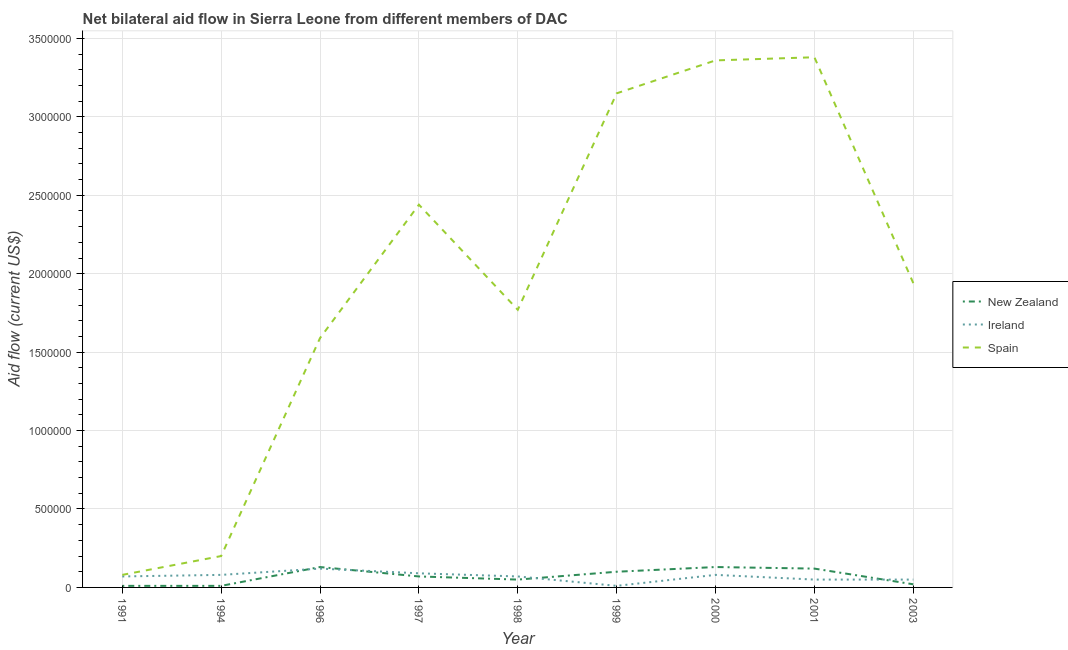How many different coloured lines are there?
Ensure brevity in your answer.  3. Is the number of lines equal to the number of legend labels?
Ensure brevity in your answer.  Yes. What is the amount of aid provided by spain in 1991?
Provide a succinct answer. 8.00e+04. Across all years, what is the maximum amount of aid provided by spain?
Give a very brief answer. 3.38e+06. Across all years, what is the minimum amount of aid provided by ireland?
Your answer should be compact. 10000. In which year was the amount of aid provided by new zealand maximum?
Your answer should be very brief. 1996. What is the total amount of aid provided by new zealand in the graph?
Give a very brief answer. 6.40e+05. What is the difference between the amount of aid provided by new zealand in 1998 and that in 1999?
Make the answer very short. -5.00e+04. What is the difference between the amount of aid provided by ireland in 1991 and the amount of aid provided by new zealand in 1996?
Keep it short and to the point. -6.00e+04. What is the average amount of aid provided by new zealand per year?
Make the answer very short. 7.11e+04. In the year 1991, what is the difference between the amount of aid provided by new zealand and amount of aid provided by ireland?
Ensure brevity in your answer.  -6.00e+04. What is the ratio of the amount of aid provided by new zealand in 1996 to that in 2003?
Your answer should be compact. 6.5. Is the amount of aid provided by ireland in 1991 less than that in 1996?
Provide a short and direct response. Yes. Is the difference between the amount of aid provided by ireland in 1991 and 2000 greater than the difference between the amount of aid provided by new zealand in 1991 and 2000?
Your response must be concise. Yes. What is the difference between the highest and the second highest amount of aid provided by spain?
Your answer should be compact. 2.00e+04. What is the difference between the highest and the lowest amount of aid provided by ireland?
Your response must be concise. 1.10e+05. Is it the case that in every year, the sum of the amount of aid provided by new zealand and amount of aid provided by ireland is greater than the amount of aid provided by spain?
Your response must be concise. No. Does the amount of aid provided by spain monotonically increase over the years?
Your answer should be compact. No. How many lines are there?
Provide a succinct answer. 3. How many years are there in the graph?
Provide a succinct answer. 9. Are the values on the major ticks of Y-axis written in scientific E-notation?
Offer a very short reply. No. Does the graph contain grids?
Make the answer very short. Yes. How many legend labels are there?
Your answer should be compact. 3. What is the title of the graph?
Provide a succinct answer. Net bilateral aid flow in Sierra Leone from different members of DAC. What is the Aid flow (current US$) in Spain in 1991?
Keep it short and to the point. 8.00e+04. What is the Aid flow (current US$) in New Zealand in 1994?
Provide a short and direct response. 10000. What is the Aid flow (current US$) in New Zealand in 1996?
Provide a short and direct response. 1.30e+05. What is the Aid flow (current US$) of Ireland in 1996?
Keep it short and to the point. 1.20e+05. What is the Aid flow (current US$) of Spain in 1996?
Keep it short and to the point. 1.59e+06. What is the Aid flow (current US$) in New Zealand in 1997?
Offer a terse response. 7.00e+04. What is the Aid flow (current US$) of Spain in 1997?
Give a very brief answer. 2.44e+06. What is the Aid flow (current US$) in Spain in 1998?
Provide a succinct answer. 1.77e+06. What is the Aid flow (current US$) of Ireland in 1999?
Provide a succinct answer. 10000. What is the Aid flow (current US$) of Spain in 1999?
Your answer should be compact. 3.15e+06. What is the Aid flow (current US$) of New Zealand in 2000?
Make the answer very short. 1.30e+05. What is the Aid flow (current US$) in Spain in 2000?
Make the answer very short. 3.36e+06. What is the Aid flow (current US$) in Ireland in 2001?
Offer a very short reply. 5.00e+04. What is the Aid flow (current US$) in Spain in 2001?
Keep it short and to the point. 3.38e+06. What is the Aid flow (current US$) in Spain in 2003?
Give a very brief answer. 1.94e+06. Across all years, what is the maximum Aid flow (current US$) in Spain?
Ensure brevity in your answer.  3.38e+06. Across all years, what is the minimum Aid flow (current US$) in Ireland?
Provide a short and direct response. 10000. Across all years, what is the minimum Aid flow (current US$) of Spain?
Your answer should be compact. 8.00e+04. What is the total Aid flow (current US$) of New Zealand in the graph?
Your answer should be very brief. 6.40e+05. What is the total Aid flow (current US$) in Ireland in the graph?
Offer a very short reply. 6.20e+05. What is the total Aid flow (current US$) in Spain in the graph?
Ensure brevity in your answer.  1.79e+07. What is the difference between the Aid flow (current US$) in Ireland in 1991 and that in 1994?
Provide a short and direct response. -10000. What is the difference between the Aid flow (current US$) in Spain in 1991 and that in 1994?
Ensure brevity in your answer.  -1.20e+05. What is the difference between the Aid flow (current US$) in New Zealand in 1991 and that in 1996?
Your answer should be very brief. -1.20e+05. What is the difference between the Aid flow (current US$) in Spain in 1991 and that in 1996?
Your response must be concise. -1.51e+06. What is the difference between the Aid flow (current US$) of Ireland in 1991 and that in 1997?
Give a very brief answer. -2.00e+04. What is the difference between the Aid flow (current US$) of Spain in 1991 and that in 1997?
Offer a terse response. -2.36e+06. What is the difference between the Aid flow (current US$) of New Zealand in 1991 and that in 1998?
Give a very brief answer. -4.00e+04. What is the difference between the Aid flow (current US$) in Ireland in 1991 and that in 1998?
Provide a succinct answer. 0. What is the difference between the Aid flow (current US$) in Spain in 1991 and that in 1998?
Offer a terse response. -1.69e+06. What is the difference between the Aid flow (current US$) in New Zealand in 1991 and that in 1999?
Your answer should be compact. -9.00e+04. What is the difference between the Aid flow (current US$) of Ireland in 1991 and that in 1999?
Provide a short and direct response. 6.00e+04. What is the difference between the Aid flow (current US$) in Spain in 1991 and that in 1999?
Ensure brevity in your answer.  -3.07e+06. What is the difference between the Aid flow (current US$) of Spain in 1991 and that in 2000?
Provide a succinct answer. -3.28e+06. What is the difference between the Aid flow (current US$) of Ireland in 1991 and that in 2001?
Your response must be concise. 2.00e+04. What is the difference between the Aid flow (current US$) of Spain in 1991 and that in 2001?
Your response must be concise. -3.30e+06. What is the difference between the Aid flow (current US$) in Ireland in 1991 and that in 2003?
Make the answer very short. 2.00e+04. What is the difference between the Aid flow (current US$) of Spain in 1991 and that in 2003?
Provide a short and direct response. -1.86e+06. What is the difference between the Aid flow (current US$) of New Zealand in 1994 and that in 1996?
Offer a terse response. -1.20e+05. What is the difference between the Aid flow (current US$) of Spain in 1994 and that in 1996?
Your answer should be compact. -1.39e+06. What is the difference between the Aid flow (current US$) of New Zealand in 1994 and that in 1997?
Offer a very short reply. -6.00e+04. What is the difference between the Aid flow (current US$) of Ireland in 1994 and that in 1997?
Offer a terse response. -10000. What is the difference between the Aid flow (current US$) in Spain in 1994 and that in 1997?
Offer a terse response. -2.24e+06. What is the difference between the Aid flow (current US$) in Ireland in 1994 and that in 1998?
Give a very brief answer. 10000. What is the difference between the Aid flow (current US$) in Spain in 1994 and that in 1998?
Keep it short and to the point. -1.57e+06. What is the difference between the Aid flow (current US$) of New Zealand in 1994 and that in 1999?
Provide a short and direct response. -9.00e+04. What is the difference between the Aid flow (current US$) of Ireland in 1994 and that in 1999?
Offer a very short reply. 7.00e+04. What is the difference between the Aid flow (current US$) of Spain in 1994 and that in 1999?
Give a very brief answer. -2.95e+06. What is the difference between the Aid flow (current US$) of New Zealand in 1994 and that in 2000?
Ensure brevity in your answer.  -1.20e+05. What is the difference between the Aid flow (current US$) of Spain in 1994 and that in 2000?
Ensure brevity in your answer.  -3.16e+06. What is the difference between the Aid flow (current US$) of New Zealand in 1994 and that in 2001?
Make the answer very short. -1.10e+05. What is the difference between the Aid flow (current US$) of Ireland in 1994 and that in 2001?
Provide a succinct answer. 3.00e+04. What is the difference between the Aid flow (current US$) in Spain in 1994 and that in 2001?
Your answer should be compact. -3.18e+06. What is the difference between the Aid flow (current US$) of Ireland in 1994 and that in 2003?
Ensure brevity in your answer.  3.00e+04. What is the difference between the Aid flow (current US$) in Spain in 1994 and that in 2003?
Make the answer very short. -1.74e+06. What is the difference between the Aid flow (current US$) of Ireland in 1996 and that in 1997?
Ensure brevity in your answer.  3.00e+04. What is the difference between the Aid flow (current US$) in Spain in 1996 and that in 1997?
Ensure brevity in your answer.  -8.50e+05. What is the difference between the Aid flow (current US$) of New Zealand in 1996 and that in 1998?
Offer a terse response. 8.00e+04. What is the difference between the Aid flow (current US$) in New Zealand in 1996 and that in 1999?
Provide a succinct answer. 3.00e+04. What is the difference between the Aid flow (current US$) of Spain in 1996 and that in 1999?
Offer a terse response. -1.56e+06. What is the difference between the Aid flow (current US$) in New Zealand in 1996 and that in 2000?
Your answer should be very brief. 0. What is the difference between the Aid flow (current US$) in Ireland in 1996 and that in 2000?
Keep it short and to the point. 4.00e+04. What is the difference between the Aid flow (current US$) of Spain in 1996 and that in 2000?
Offer a terse response. -1.77e+06. What is the difference between the Aid flow (current US$) of New Zealand in 1996 and that in 2001?
Keep it short and to the point. 10000. What is the difference between the Aid flow (current US$) in Spain in 1996 and that in 2001?
Offer a very short reply. -1.79e+06. What is the difference between the Aid flow (current US$) in Spain in 1996 and that in 2003?
Give a very brief answer. -3.50e+05. What is the difference between the Aid flow (current US$) in New Zealand in 1997 and that in 1998?
Your answer should be very brief. 2.00e+04. What is the difference between the Aid flow (current US$) in Spain in 1997 and that in 1998?
Offer a very short reply. 6.70e+05. What is the difference between the Aid flow (current US$) in New Zealand in 1997 and that in 1999?
Offer a very short reply. -3.00e+04. What is the difference between the Aid flow (current US$) in Spain in 1997 and that in 1999?
Offer a very short reply. -7.10e+05. What is the difference between the Aid flow (current US$) of Spain in 1997 and that in 2000?
Your response must be concise. -9.20e+05. What is the difference between the Aid flow (current US$) in Spain in 1997 and that in 2001?
Your response must be concise. -9.40e+05. What is the difference between the Aid flow (current US$) of Ireland in 1997 and that in 2003?
Your answer should be compact. 4.00e+04. What is the difference between the Aid flow (current US$) of Ireland in 1998 and that in 1999?
Keep it short and to the point. 6.00e+04. What is the difference between the Aid flow (current US$) in Spain in 1998 and that in 1999?
Your answer should be compact. -1.38e+06. What is the difference between the Aid flow (current US$) of Ireland in 1998 and that in 2000?
Provide a succinct answer. -10000. What is the difference between the Aid flow (current US$) of Spain in 1998 and that in 2000?
Give a very brief answer. -1.59e+06. What is the difference between the Aid flow (current US$) of Ireland in 1998 and that in 2001?
Provide a succinct answer. 2.00e+04. What is the difference between the Aid flow (current US$) of Spain in 1998 and that in 2001?
Make the answer very short. -1.61e+06. What is the difference between the Aid flow (current US$) of Ireland in 1998 and that in 2003?
Ensure brevity in your answer.  2.00e+04. What is the difference between the Aid flow (current US$) in Spain in 1998 and that in 2003?
Offer a terse response. -1.70e+05. What is the difference between the Aid flow (current US$) of Ireland in 1999 and that in 2000?
Ensure brevity in your answer.  -7.00e+04. What is the difference between the Aid flow (current US$) of New Zealand in 1999 and that in 2001?
Give a very brief answer. -2.00e+04. What is the difference between the Aid flow (current US$) in Ireland in 1999 and that in 2001?
Your response must be concise. -4.00e+04. What is the difference between the Aid flow (current US$) of Spain in 1999 and that in 2001?
Your answer should be very brief. -2.30e+05. What is the difference between the Aid flow (current US$) in New Zealand in 1999 and that in 2003?
Offer a terse response. 8.00e+04. What is the difference between the Aid flow (current US$) of Ireland in 1999 and that in 2003?
Your response must be concise. -4.00e+04. What is the difference between the Aid flow (current US$) of Spain in 1999 and that in 2003?
Provide a short and direct response. 1.21e+06. What is the difference between the Aid flow (current US$) in Spain in 2000 and that in 2001?
Give a very brief answer. -2.00e+04. What is the difference between the Aid flow (current US$) in Ireland in 2000 and that in 2003?
Give a very brief answer. 3.00e+04. What is the difference between the Aid flow (current US$) of Spain in 2000 and that in 2003?
Keep it short and to the point. 1.42e+06. What is the difference between the Aid flow (current US$) of Spain in 2001 and that in 2003?
Your answer should be very brief. 1.44e+06. What is the difference between the Aid flow (current US$) in New Zealand in 1991 and the Aid flow (current US$) in Ireland in 1994?
Offer a terse response. -7.00e+04. What is the difference between the Aid flow (current US$) in Ireland in 1991 and the Aid flow (current US$) in Spain in 1994?
Your answer should be very brief. -1.30e+05. What is the difference between the Aid flow (current US$) in New Zealand in 1991 and the Aid flow (current US$) in Spain in 1996?
Ensure brevity in your answer.  -1.58e+06. What is the difference between the Aid flow (current US$) of Ireland in 1991 and the Aid flow (current US$) of Spain in 1996?
Give a very brief answer. -1.52e+06. What is the difference between the Aid flow (current US$) in New Zealand in 1991 and the Aid flow (current US$) in Spain in 1997?
Give a very brief answer. -2.43e+06. What is the difference between the Aid flow (current US$) in Ireland in 1991 and the Aid flow (current US$) in Spain in 1997?
Give a very brief answer. -2.37e+06. What is the difference between the Aid flow (current US$) of New Zealand in 1991 and the Aid flow (current US$) of Ireland in 1998?
Provide a succinct answer. -6.00e+04. What is the difference between the Aid flow (current US$) of New Zealand in 1991 and the Aid flow (current US$) of Spain in 1998?
Your answer should be very brief. -1.76e+06. What is the difference between the Aid flow (current US$) of Ireland in 1991 and the Aid flow (current US$) of Spain in 1998?
Offer a very short reply. -1.70e+06. What is the difference between the Aid flow (current US$) in New Zealand in 1991 and the Aid flow (current US$) in Spain in 1999?
Offer a very short reply. -3.14e+06. What is the difference between the Aid flow (current US$) in Ireland in 1991 and the Aid flow (current US$) in Spain in 1999?
Your answer should be very brief. -3.08e+06. What is the difference between the Aid flow (current US$) in New Zealand in 1991 and the Aid flow (current US$) in Ireland in 2000?
Your answer should be compact. -7.00e+04. What is the difference between the Aid flow (current US$) of New Zealand in 1991 and the Aid flow (current US$) of Spain in 2000?
Give a very brief answer. -3.35e+06. What is the difference between the Aid flow (current US$) in Ireland in 1991 and the Aid flow (current US$) in Spain in 2000?
Provide a succinct answer. -3.29e+06. What is the difference between the Aid flow (current US$) of New Zealand in 1991 and the Aid flow (current US$) of Ireland in 2001?
Keep it short and to the point. -4.00e+04. What is the difference between the Aid flow (current US$) of New Zealand in 1991 and the Aid flow (current US$) of Spain in 2001?
Offer a very short reply. -3.37e+06. What is the difference between the Aid flow (current US$) of Ireland in 1991 and the Aid flow (current US$) of Spain in 2001?
Offer a very short reply. -3.31e+06. What is the difference between the Aid flow (current US$) of New Zealand in 1991 and the Aid flow (current US$) of Spain in 2003?
Make the answer very short. -1.93e+06. What is the difference between the Aid flow (current US$) of Ireland in 1991 and the Aid flow (current US$) of Spain in 2003?
Provide a succinct answer. -1.87e+06. What is the difference between the Aid flow (current US$) in New Zealand in 1994 and the Aid flow (current US$) in Ireland in 1996?
Give a very brief answer. -1.10e+05. What is the difference between the Aid flow (current US$) of New Zealand in 1994 and the Aid flow (current US$) of Spain in 1996?
Offer a terse response. -1.58e+06. What is the difference between the Aid flow (current US$) of Ireland in 1994 and the Aid flow (current US$) of Spain in 1996?
Your answer should be very brief. -1.51e+06. What is the difference between the Aid flow (current US$) of New Zealand in 1994 and the Aid flow (current US$) of Ireland in 1997?
Provide a succinct answer. -8.00e+04. What is the difference between the Aid flow (current US$) in New Zealand in 1994 and the Aid flow (current US$) in Spain in 1997?
Keep it short and to the point. -2.43e+06. What is the difference between the Aid flow (current US$) of Ireland in 1994 and the Aid flow (current US$) of Spain in 1997?
Your response must be concise. -2.36e+06. What is the difference between the Aid flow (current US$) of New Zealand in 1994 and the Aid flow (current US$) of Spain in 1998?
Provide a short and direct response. -1.76e+06. What is the difference between the Aid flow (current US$) in Ireland in 1994 and the Aid flow (current US$) in Spain in 1998?
Your answer should be very brief. -1.69e+06. What is the difference between the Aid flow (current US$) of New Zealand in 1994 and the Aid flow (current US$) of Spain in 1999?
Your answer should be compact. -3.14e+06. What is the difference between the Aid flow (current US$) of Ireland in 1994 and the Aid flow (current US$) of Spain in 1999?
Provide a short and direct response. -3.07e+06. What is the difference between the Aid flow (current US$) of New Zealand in 1994 and the Aid flow (current US$) of Spain in 2000?
Your answer should be very brief. -3.35e+06. What is the difference between the Aid flow (current US$) in Ireland in 1994 and the Aid flow (current US$) in Spain in 2000?
Your answer should be compact. -3.28e+06. What is the difference between the Aid flow (current US$) in New Zealand in 1994 and the Aid flow (current US$) in Spain in 2001?
Your response must be concise. -3.37e+06. What is the difference between the Aid flow (current US$) of Ireland in 1994 and the Aid flow (current US$) of Spain in 2001?
Offer a very short reply. -3.30e+06. What is the difference between the Aid flow (current US$) in New Zealand in 1994 and the Aid flow (current US$) in Ireland in 2003?
Offer a very short reply. -4.00e+04. What is the difference between the Aid flow (current US$) of New Zealand in 1994 and the Aid flow (current US$) of Spain in 2003?
Offer a terse response. -1.93e+06. What is the difference between the Aid flow (current US$) in Ireland in 1994 and the Aid flow (current US$) in Spain in 2003?
Ensure brevity in your answer.  -1.86e+06. What is the difference between the Aid flow (current US$) in New Zealand in 1996 and the Aid flow (current US$) in Ireland in 1997?
Keep it short and to the point. 4.00e+04. What is the difference between the Aid flow (current US$) of New Zealand in 1996 and the Aid flow (current US$) of Spain in 1997?
Offer a very short reply. -2.31e+06. What is the difference between the Aid flow (current US$) in Ireland in 1996 and the Aid flow (current US$) in Spain in 1997?
Ensure brevity in your answer.  -2.32e+06. What is the difference between the Aid flow (current US$) in New Zealand in 1996 and the Aid flow (current US$) in Ireland in 1998?
Your answer should be very brief. 6.00e+04. What is the difference between the Aid flow (current US$) of New Zealand in 1996 and the Aid flow (current US$) of Spain in 1998?
Ensure brevity in your answer.  -1.64e+06. What is the difference between the Aid flow (current US$) of Ireland in 1996 and the Aid flow (current US$) of Spain in 1998?
Offer a terse response. -1.65e+06. What is the difference between the Aid flow (current US$) in New Zealand in 1996 and the Aid flow (current US$) in Ireland in 1999?
Keep it short and to the point. 1.20e+05. What is the difference between the Aid flow (current US$) of New Zealand in 1996 and the Aid flow (current US$) of Spain in 1999?
Make the answer very short. -3.02e+06. What is the difference between the Aid flow (current US$) of Ireland in 1996 and the Aid flow (current US$) of Spain in 1999?
Give a very brief answer. -3.03e+06. What is the difference between the Aid flow (current US$) in New Zealand in 1996 and the Aid flow (current US$) in Spain in 2000?
Your answer should be compact. -3.23e+06. What is the difference between the Aid flow (current US$) of Ireland in 1996 and the Aid flow (current US$) of Spain in 2000?
Provide a succinct answer. -3.24e+06. What is the difference between the Aid flow (current US$) in New Zealand in 1996 and the Aid flow (current US$) in Spain in 2001?
Your answer should be compact. -3.25e+06. What is the difference between the Aid flow (current US$) of Ireland in 1996 and the Aid flow (current US$) of Spain in 2001?
Your response must be concise. -3.26e+06. What is the difference between the Aid flow (current US$) of New Zealand in 1996 and the Aid flow (current US$) of Ireland in 2003?
Keep it short and to the point. 8.00e+04. What is the difference between the Aid flow (current US$) in New Zealand in 1996 and the Aid flow (current US$) in Spain in 2003?
Make the answer very short. -1.81e+06. What is the difference between the Aid flow (current US$) of Ireland in 1996 and the Aid flow (current US$) of Spain in 2003?
Provide a succinct answer. -1.82e+06. What is the difference between the Aid flow (current US$) of New Zealand in 1997 and the Aid flow (current US$) of Ireland in 1998?
Give a very brief answer. 0. What is the difference between the Aid flow (current US$) of New Zealand in 1997 and the Aid flow (current US$) of Spain in 1998?
Your answer should be compact. -1.70e+06. What is the difference between the Aid flow (current US$) in Ireland in 1997 and the Aid flow (current US$) in Spain in 1998?
Keep it short and to the point. -1.68e+06. What is the difference between the Aid flow (current US$) in New Zealand in 1997 and the Aid flow (current US$) in Spain in 1999?
Provide a short and direct response. -3.08e+06. What is the difference between the Aid flow (current US$) of Ireland in 1997 and the Aid flow (current US$) of Spain in 1999?
Give a very brief answer. -3.06e+06. What is the difference between the Aid flow (current US$) of New Zealand in 1997 and the Aid flow (current US$) of Ireland in 2000?
Your answer should be very brief. -10000. What is the difference between the Aid flow (current US$) of New Zealand in 1997 and the Aid flow (current US$) of Spain in 2000?
Offer a terse response. -3.29e+06. What is the difference between the Aid flow (current US$) of Ireland in 1997 and the Aid flow (current US$) of Spain in 2000?
Offer a terse response. -3.27e+06. What is the difference between the Aid flow (current US$) in New Zealand in 1997 and the Aid flow (current US$) in Ireland in 2001?
Provide a short and direct response. 2.00e+04. What is the difference between the Aid flow (current US$) of New Zealand in 1997 and the Aid flow (current US$) of Spain in 2001?
Provide a short and direct response. -3.31e+06. What is the difference between the Aid flow (current US$) of Ireland in 1997 and the Aid flow (current US$) of Spain in 2001?
Offer a terse response. -3.29e+06. What is the difference between the Aid flow (current US$) in New Zealand in 1997 and the Aid flow (current US$) in Spain in 2003?
Ensure brevity in your answer.  -1.87e+06. What is the difference between the Aid flow (current US$) of Ireland in 1997 and the Aid flow (current US$) of Spain in 2003?
Provide a succinct answer. -1.85e+06. What is the difference between the Aid flow (current US$) in New Zealand in 1998 and the Aid flow (current US$) in Spain in 1999?
Provide a short and direct response. -3.10e+06. What is the difference between the Aid flow (current US$) of Ireland in 1998 and the Aid flow (current US$) of Spain in 1999?
Offer a very short reply. -3.08e+06. What is the difference between the Aid flow (current US$) in New Zealand in 1998 and the Aid flow (current US$) in Spain in 2000?
Your response must be concise. -3.31e+06. What is the difference between the Aid flow (current US$) in Ireland in 1998 and the Aid flow (current US$) in Spain in 2000?
Provide a succinct answer. -3.29e+06. What is the difference between the Aid flow (current US$) in New Zealand in 1998 and the Aid flow (current US$) in Ireland in 2001?
Keep it short and to the point. 0. What is the difference between the Aid flow (current US$) in New Zealand in 1998 and the Aid flow (current US$) in Spain in 2001?
Make the answer very short. -3.33e+06. What is the difference between the Aid flow (current US$) in Ireland in 1998 and the Aid flow (current US$) in Spain in 2001?
Offer a terse response. -3.31e+06. What is the difference between the Aid flow (current US$) in New Zealand in 1998 and the Aid flow (current US$) in Spain in 2003?
Your answer should be compact. -1.89e+06. What is the difference between the Aid flow (current US$) of Ireland in 1998 and the Aid flow (current US$) of Spain in 2003?
Offer a very short reply. -1.87e+06. What is the difference between the Aid flow (current US$) in New Zealand in 1999 and the Aid flow (current US$) in Ireland in 2000?
Offer a very short reply. 2.00e+04. What is the difference between the Aid flow (current US$) in New Zealand in 1999 and the Aid flow (current US$) in Spain in 2000?
Your answer should be compact. -3.26e+06. What is the difference between the Aid flow (current US$) in Ireland in 1999 and the Aid flow (current US$) in Spain in 2000?
Offer a terse response. -3.35e+06. What is the difference between the Aid flow (current US$) in New Zealand in 1999 and the Aid flow (current US$) in Spain in 2001?
Offer a terse response. -3.28e+06. What is the difference between the Aid flow (current US$) in Ireland in 1999 and the Aid flow (current US$) in Spain in 2001?
Make the answer very short. -3.37e+06. What is the difference between the Aid flow (current US$) of New Zealand in 1999 and the Aid flow (current US$) of Ireland in 2003?
Your answer should be very brief. 5.00e+04. What is the difference between the Aid flow (current US$) in New Zealand in 1999 and the Aid flow (current US$) in Spain in 2003?
Ensure brevity in your answer.  -1.84e+06. What is the difference between the Aid flow (current US$) in Ireland in 1999 and the Aid flow (current US$) in Spain in 2003?
Keep it short and to the point. -1.93e+06. What is the difference between the Aid flow (current US$) in New Zealand in 2000 and the Aid flow (current US$) in Ireland in 2001?
Provide a succinct answer. 8.00e+04. What is the difference between the Aid flow (current US$) of New Zealand in 2000 and the Aid flow (current US$) of Spain in 2001?
Make the answer very short. -3.25e+06. What is the difference between the Aid flow (current US$) of Ireland in 2000 and the Aid flow (current US$) of Spain in 2001?
Offer a very short reply. -3.30e+06. What is the difference between the Aid flow (current US$) in New Zealand in 2000 and the Aid flow (current US$) in Spain in 2003?
Your response must be concise. -1.81e+06. What is the difference between the Aid flow (current US$) in Ireland in 2000 and the Aid flow (current US$) in Spain in 2003?
Ensure brevity in your answer.  -1.86e+06. What is the difference between the Aid flow (current US$) of New Zealand in 2001 and the Aid flow (current US$) of Ireland in 2003?
Your answer should be very brief. 7.00e+04. What is the difference between the Aid flow (current US$) of New Zealand in 2001 and the Aid flow (current US$) of Spain in 2003?
Provide a succinct answer. -1.82e+06. What is the difference between the Aid flow (current US$) of Ireland in 2001 and the Aid flow (current US$) of Spain in 2003?
Give a very brief answer. -1.89e+06. What is the average Aid flow (current US$) in New Zealand per year?
Offer a very short reply. 7.11e+04. What is the average Aid flow (current US$) of Ireland per year?
Your answer should be very brief. 6.89e+04. What is the average Aid flow (current US$) in Spain per year?
Offer a terse response. 1.99e+06. In the year 1991, what is the difference between the Aid flow (current US$) of Ireland and Aid flow (current US$) of Spain?
Your response must be concise. -10000. In the year 1996, what is the difference between the Aid flow (current US$) of New Zealand and Aid flow (current US$) of Ireland?
Provide a succinct answer. 10000. In the year 1996, what is the difference between the Aid flow (current US$) in New Zealand and Aid flow (current US$) in Spain?
Provide a short and direct response. -1.46e+06. In the year 1996, what is the difference between the Aid flow (current US$) in Ireland and Aid flow (current US$) in Spain?
Provide a succinct answer. -1.47e+06. In the year 1997, what is the difference between the Aid flow (current US$) of New Zealand and Aid flow (current US$) of Ireland?
Your answer should be compact. -2.00e+04. In the year 1997, what is the difference between the Aid flow (current US$) in New Zealand and Aid flow (current US$) in Spain?
Ensure brevity in your answer.  -2.37e+06. In the year 1997, what is the difference between the Aid flow (current US$) in Ireland and Aid flow (current US$) in Spain?
Your answer should be very brief. -2.35e+06. In the year 1998, what is the difference between the Aid flow (current US$) in New Zealand and Aid flow (current US$) in Spain?
Your response must be concise. -1.72e+06. In the year 1998, what is the difference between the Aid flow (current US$) in Ireland and Aid flow (current US$) in Spain?
Provide a short and direct response. -1.70e+06. In the year 1999, what is the difference between the Aid flow (current US$) of New Zealand and Aid flow (current US$) of Spain?
Your answer should be compact. -3.05e+06. In the year 1999, what is the difference between the Aid flow (current US$) of Ireland and Aid flow (current US$) of Spain?
Make the answer very short. -3.14e+06. In the year 2000, what is the difference between the Aid flow (current US$) in New Zealand and Aid flow (current US$) in Ireland?
Provide a succinct answer. 5.00e+04. In the year 2000, what is the difference between the Aid flow (current US$) of New Zealand and Aid flow (current US$) of Spain?
Offer a terse response. -3.23e+06. In the year 2000, what is the difference between the Aid flow (current US$) in Ireland and Aid flow (current US$) in Spain?
Offer a very short reply. -3.28e+06. In the year 2001, what is the difference between the Aid flow (current US$) of New Zealand and Aid flow (current US$) of Spain?
Offer a very short reply. -3.26e+06. In the year 2001, what is the difference between the Aid flow (current US$) of Ireland and Aid flow (current US$) of Spain?
Provide a short and direct response. -3.33e+06. In the year 2003, what is the difference between the Aid flow (current US$) in New Zealand and Aid flow (current US$) in Ireland?
Ensure brevity in your answer.  -3.00e+04. In the year 2003, what is the difference between the Aid flow (current US$) of New Zealand and Aid flow (current US$) of Spain?
Offer a very short reply. -1.92e+06. In the year 2003, what is the difference between the Aid flow (current US$) in Ireland and Aid flow (current US$) in Spain?
Your answer should be compact. -1.89e+06. What is the ratio of the Aid flow (current US$) in Ireland in 1991 to that in 1994?
Provide a succinct answer. 0.88. What is the ratio of the Aid flow (current US$) in New Zealand in 1991 to that in 1996?
Make the answer very short. 0.08. What is the ratio of the Aid flow (current US$) of Ireland in 1991 to that in 1996?
Keep it short and to the point. 0.58. What is the ratio of the Aid flow (current US$) in Spain in 1991 to that in 1996?
Offer a very short reply. 0.05. What is the ratio of the Aid flow (current US$) of New Zealand in 1991 to that in 1997?
Ensure brevity in your answer.  0.14. What is the ratio of the Aid flow (current US$) of Spain in 1991 to that in 1997?
Your response must be concise. 0.03. What is the ratio of the Aid flow (current US$) of New Zealand in 1991 to that in 1998?
Your response must be concise. 0.2. What is the ratio of the Aid flow (current US$) of Spain in 1991 to that in 1998?
Your answer should be compact. 0.05. What is the ratio of the Aid flow (current US$) in New Zealand in 1991 to that in 1999?
Your answer should be very brief. 0.1. What is the ratio of the Aid flow (current US$) in Ireland in 1991 to that in 1999?
Your answer should be very brief. 7. What is the ratio of the Aid flow (current US$) of Spain in 1991 to that in 1999?
Ensure brevity in your answer.  0.03. What is the ratio of the Aid flow (current US$) in New Zealand in 1991 to that in 2000?
Make the answer very short. 0.08. What is the ratio of the Aid flow (current US$) in Ireland in 1991 to that in 2000?
Keep it short and to the point. 0.88. What is the ratio of the Aid flow (current US$) of Spain in 1991 to that in 2000?
Offer a very short reply. 0.02. What is the ratio of the Aid flow (current US$) of New Zealand in 1991 to that in 2001?
Ensure brevity in your answer.  0.08. What is the ratio of the Aid flow (current US$) in Spain in 1991 to that in 2001?
Your answer should be very brief. 0.02. What is the ratio of the Aid flow (current US$) in New Zealand in 1991 to that in 2003?
Make the answer very short. 0.5. What is the ratio of the Aid flow (current US$) of Spain in 1991 to that in 2003?
Provide a succinct answer. 0.04. What is the ratio of the Aid flow (current US$) of New Zealand in 1994 to that in 1996?
Make the answer very short. 0.08. What is the ratio of the Aid flow (current US$) of Ireland in 1994 to that in 1996?
Offer a very short reply. 0.67. What is the ratio of the Aid flow (current US$) of Spain in 1994 to that in 1996?
Provide a succinct answer. 0.13. What is the ratio of the Aid flow (current US$) in New Zealand in 1994 to that in 1997?
Make the answer very short. 0.14. What is the ratio of the Aid flow (current US$) of Ireland in 1994 to that in 1997?
Provide a succinct answer. 0.89. What is the ratio of the Aid flow (current US$) of Spain in 1994 to that in 1997?
Offer a very short reply. 0.08. What is the ratio of the Aid flow (current US$) of Ireland in 1994 to that in 1998?
Offer a terse response. 1.14. What is the ratio of the Aid flow (current US$) of Spain in 1994 to that in 1998?
Give a very brief answer. 0.11. What is the ratio of the Aid flow (current US$) in New Zealand in 1994 to that in 1999?
Keep it short and to the point. 0.1. What is the ratio of the Aid flow (current US$) in Ireland in 1994 to that in 1999?
Provide a succinct answer. 8. What is the ratio of the Aid flow (current US$) of Spain in 1994 to that in 1999?
Ensure brevity in your answer.  0.06. What is the ratio of the Aid flow (current US$) of New Zealand in 1994 to that in 2000?
Make the answer very short. 0.08. What is the ratio of the Aid flow (current US$) of Spain in 1994 to that in 2000?
Your answer should be compact. 0.06. What is the ratio of the Aid flow (current US$) of New Zealand in 1994 to that in 2001?
Keep it short and to the point. 0.08. What is the ratio of the Aid flow (current US$) of Ireland in 1994 to that in 2001?
Offer a very short reply. 1.6. What is the ratio of the Aid flow (current US$) in Spain in 1994 to that in 2001?
Keep it short and to the point. 0.06. What is the ratio of the Aid flow (current US$) of Ireland in 1994 to that in 2003?
Your answer should be compact. 1.6. What is the ratio of the Aid flow (current US$) of Spain in 1994 to that in 2003?
Keep it short and to the point. 0.1. What is the ratio of the Aid flow (current US$) of New Zealand in 1996 to that in 1997?
Make the answer very short. 1.86. What is the ratio of the Aid flow (current US$) of Ireland in 1996 to that in 1997?
Your response must be concise. 1.33. What is the ratio of the Aid flow (current US$) in Spain in 1996 to that in 1997?
Provide a short and direct response. 0.65. What is the ratio of the Aid flow (current US$) of Ireland in 1996 to that in 1998?
Your answer should be compact. 1.71. What is the ratio of the Aid flow (current US$) of Spain in 1996 to that in 1998?
Provide a succinct answer. 0.9. What is the ratio of the Aid flow (current US$) of New Zealand in 1996 to that in 1999?
Offer a very short reply. 1.3. What is the ratio of the Aid flow (current US$) of Ireland in 1996 to that in 1999?
Offer a very short reply. 12. What is the ratio of the Aid flow (current US$) in Spain in 1996 to that in 1999?
Keep it short and to the point. 0.5. What is the ratio of the Aid flow (current US$) in Ireland in 1996 to that in 2000?
Give a very brief answer. 1.5. What is the ratio of the Aid flow (current US$) in Spain in 1996 to that in 2000?
Ensure brevity in your answer.  0.47. What is the ratio of the Aid flow (current US$) of Ireland in 1996 to that in 2001?
Give a very brief answer. 2.4. What is the ratio of the Aid flow (current US$) in Spain in 1996 to that in 2001?
Give a very brief answer. 0.47. What is the ratio of the Aid flow (current US$) of New Zealand in 1996 to that in 2003?
Your response must be concise. 6.5. What is the ratio of the Aid flow (current US$) of Ireland in 1996 to that in 2003?
Offer a very short reply. 2.4. What is the ratio of the Aid flow (current US$) in Spain in 1996 to that in 2003?
Offer a very short reply. 0.82. What is the ratio of the Aid flow (current US$) of Spain in 1997 to that in 1998?
Give a very brief answer. 1.38. What is the ratio of the Aid flow (current US$) of Spain in 1997 to that in 1999?
Ensure brevity in your answer.  0.77. What is the ratio of the Aid flow (current US$) of New Zealand in 1997 to that in 2000?
Offer a terse response. 0.54. What is the ratio of the Aid flow (current US$) in Spain in 1997 to that in 2000?
Ensure brevity in your answer.  0.73. What is the ratio of the Aid flow (current US$) of New Zealand in 1997 to that in 2001?
Give a very brief answer. 0.58. What is the ratio of the Aid flow (current US$) in Ireland in 1997 to that in 2001?
Your response must be concise. 1.8. What is the ratio of the Aid flow (current US$) of Spain in 1997 to that in 2001?
Keep it short and to the point. 0.72. What is the ratio of the Aid flow (current US$) of Ireland in 1997 to that in 2003?
Your answer should be very brief. 1.8. What is the ratio of the Aid flow (current US$) in Spain in 1997 to that in 2003?
Provide a succinct answer. 1.26. What is the ratio of the Aid flow (current US$) in Ireland in 1998 to that in 1999?
Your answer should be very brief. 7. What is the ratio of the Aid flow (current US$) in Spain in 1998 to that in 1999?
Your answer should be very brief. 0.56. What is the ratio of the Aid flow (current US$) of New Zealand in 1998 to that in 2000?
Provide a succinct answer. 0.38. What is the ratio of the Aid flow (current US$) in Ireland in 1998 to that in 2000?
Keep it short and to the point. 0.88. What is the ratio of the Aid flow (current US$) in Spain in 1998 to that in 2000?
Make the answer very short. 0.53. What is the ratio of the Aid flow (current US$) in New Zealand in 1998 to that in 2001?
Keep it short and to the point. 0.42. What is the ratio of the Aid flow (current US$) in Spain in 1998 to that in 2001?
Offer a terse response. 0.52. What is the ratio of the Aid flow (current US$) of New Zealand in 1998 to that in 2003?
Offer a terse response. 2.5. What is the ratio of the Aid flow (current US$) of Spain in 1998 to that in 2003?
Ensure brevity in your answer.  0.91. What is the ratio of the Aid flow (current US$) of New Zealand in 1999 to that in 2000?
Your answer should be very brief. 0.77. What is the ratio of the Aid flow (current US$) of Ireland in 1999 to that in 2000?
Ensure brevity in your answer.  0.12. What is the ratio of the Aid flow (current US$) of Spain in 1999 to that in 2000?
Offer a terse response. 0.94. What is the ratio of the Aid flow (current US$) in Spain in 1999 to that in 2001?
Provide a succinct answer. 0.93. What is the ratio of the Aid flow (current US$) in Ireland in 1999 to that in 2003?
Provide a short and direct response. 0.2. What is the ratio of the Aid flow (current US$) in Spain in 1999 to that in 2003?
Keep it short and to the point. 1.62. What is the ratio of the Aid flow (current US$) of Spain in 2000 to that in 2003?
Keep it short and to the point. 1.73. What is the ratio of the Aid flow (current US$) in Spain in 2001 to that in 2003?
Offer a very short reply. 1.74. What is the difference between the highest and the second highest Aid flow (current US$) of Spain?
Offer a very short reply. 2.00e+04. What is the difference between the highest and the lowest Aid flow (current US$) of Spain?
Offer a terse response. 3.30e+06. 